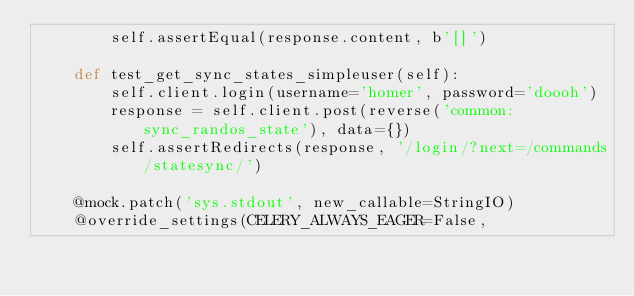<code> <loc_0><loc_0><loc_500><loc_500><_Python_>        self.assertEqual(response.content, b'[]')

    def test_get_sync_states_simpleuser(self):
        self.client.login(username='homer', password='doooh')
        response = self.client.post(reverse('common:sync_randos_state'), data={})
        self.assertRedirects(response, '/login/?next=/commands/statesync/')

    @mock.patch('sys.stdout', new_callable=StringIO)
    @override_settings(CELERY_ALWAYS_EAGER=False,</code> 